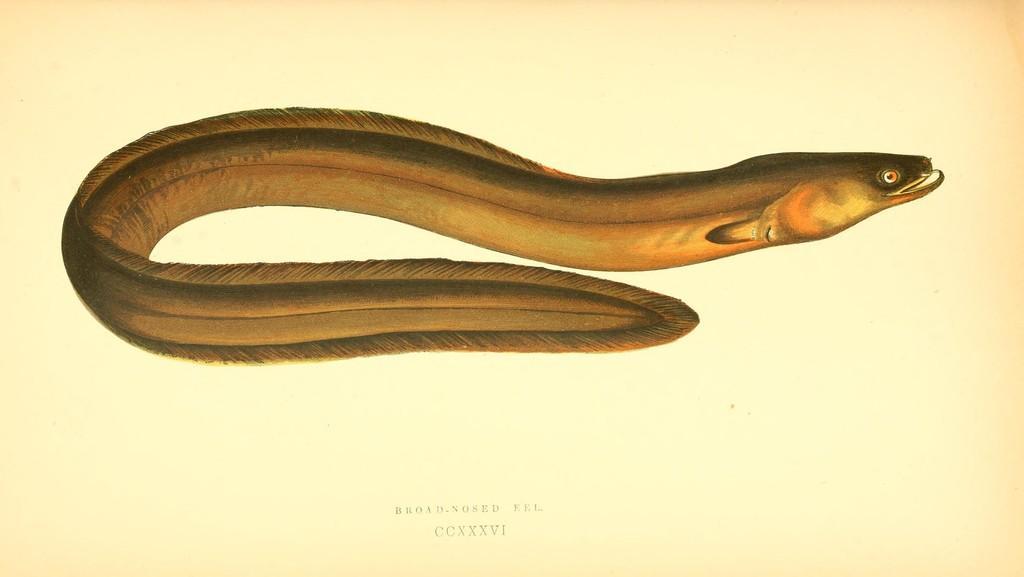How would you summarize this image in a sentence or two? In this image we can see one broad nosed eel, some text on the bottom of the image and the background is in cream color. 